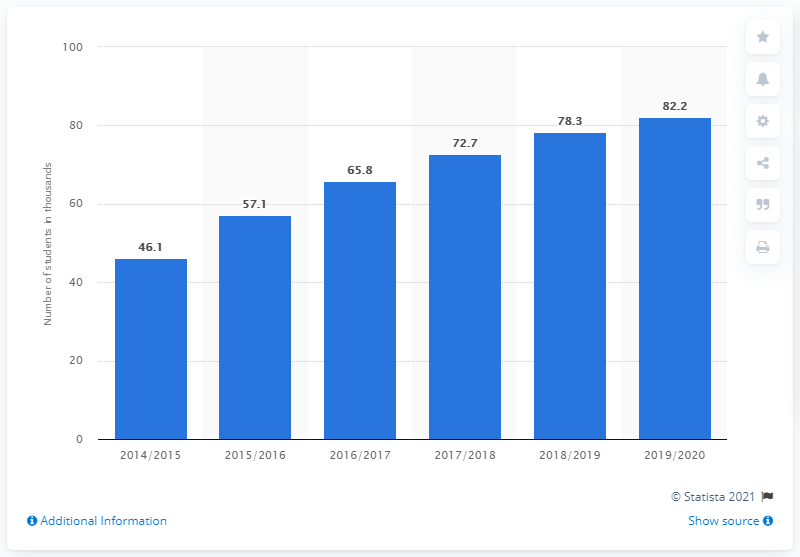Mention a couple of crucial points in this snapshot. The number of foreign students studying in Poland increased by 78.3% within five years. 